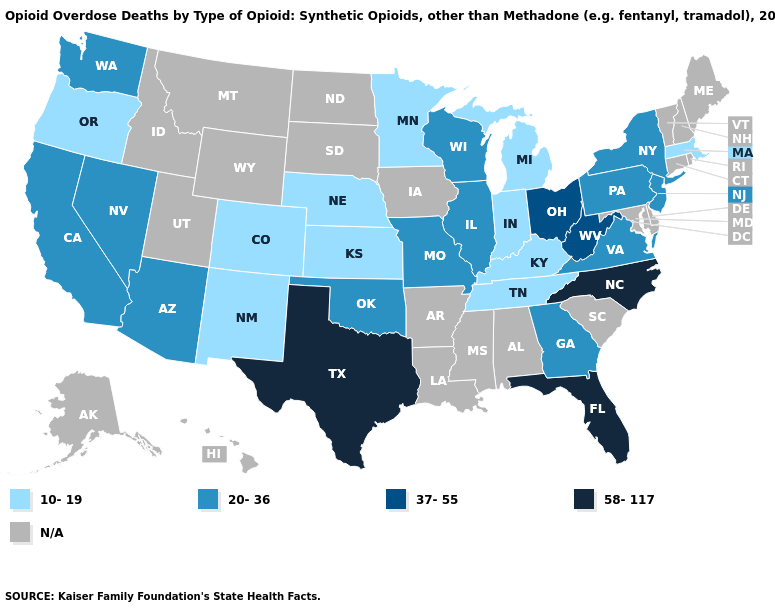Which states hav the highest value in the South?
Concise answer only. Florida, North Carolina, Texas. What is the value of Rhode Island?
Quick response, please. N/A. What is the value of Ohio?
Write a very short answer. 37-55. Does New York have the lowest value in the Northeast?
Be succinct. No. Which states hav the highest value in the Northeast?
Give a very brief answer. New Jersey, New York, Pennsylvania. What is the value of Ohio?
Concise answer only. 37-55. Name the states that have a value in the range 37-55?
Be succinct. Ohio, West Virginia. What is the value of New Jersey?
Quick response, please. 20-36. What is the value of Kansas?
Short answer required. 10-19. Name the states that have a value in the range 58-117?
Give a very brief answer. Florida, North Carolina, Texas. Does Pennsylvania have the highest value in the Northeast?
Be succinct. Yes. How many symbols are there in the legend?
Answer briefly. 5. Which states have the highest value in the USA?
Write a very short answer. Florida, North Carolina, Texas. Name the states that have a value in the range 10-19?
Write a very short answer. Colorado, Indiana, Kansas, Kentucky, Massachusetts, Michigan, Minnesota, Nebraska, New Mexico, Oregon, Tennessee. Does Georgia have the highest value in the South?
Keep it brief. No. 